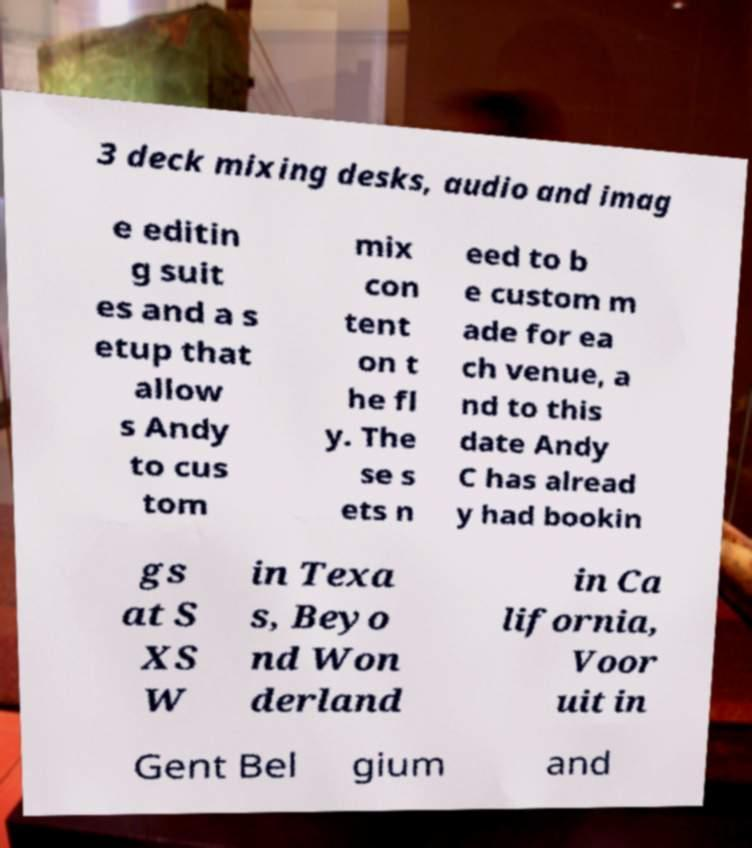Could you extract and type out the text from this image? 3 deck mixing desks, audio and imag e editin g suit es and a s etup that allow s Andy to cus tom mix con tent on t he fl y. The se s ets n eed to b e custom m ade for ea ch venue, a nd to this date Andy C has alread y had bookin gs at S XS W in Texa s, Beyo nd Won derland in Ca lifornia, Voor uit in Gent Bel gium and 